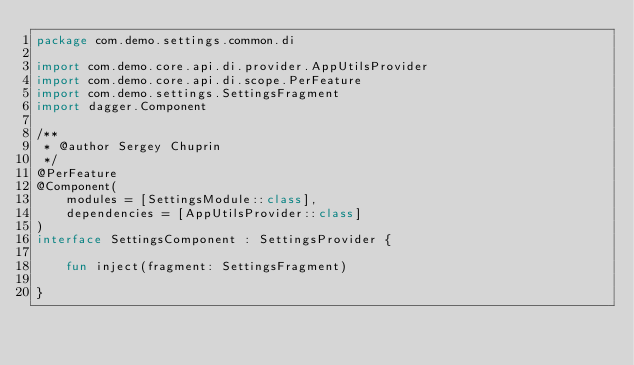<code> <loc_0><loc_0><loc_500><loc_500><_Kotlin_>package com.demo.settings.common.di

import com.demo.core.api.di.provider.AppUtilsProvider
import com.demo.core.api.di.scope.PerFeature
import com.demo.settings.SettingsFragment
import dagger.Component

/**
 * @author Sergey Chuprin
 */
@PerFeature
@Component(
    modules = [SettingsModule::class],
    dependencies = [AppUtilsProvider::class]
)
interface SettingsComponent : SettingsProvider {

    fun inject(fragment: SettingsFragment)

}</code> 